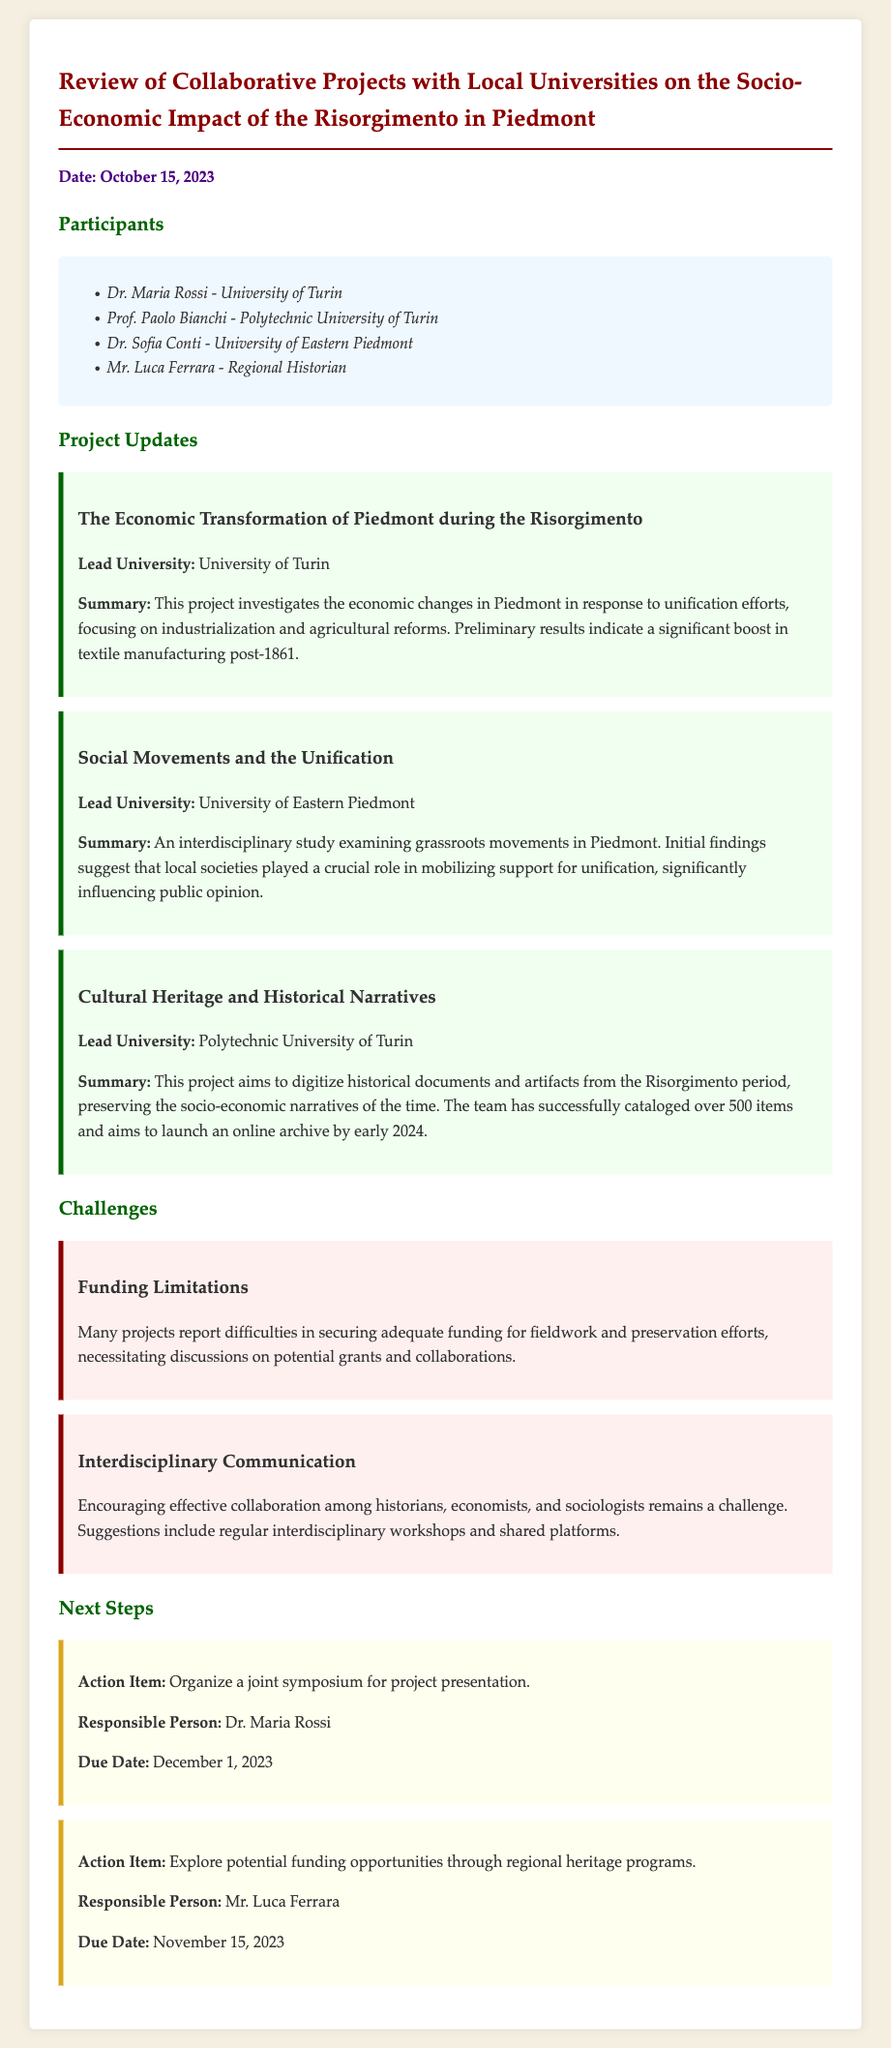What is the date of the meeting? The date of the meeting is stated prominently at the beginning of the document.
Answer: October 15, 2023 Who is the lead university for the project on economic transformation? The lead university for this project is listed under the project updates section.
Answer: University of Turin What is one of the challenges faced by the projects? The challenges are summarized in a section titled "Challenges" where each challenge is detailed.
Answer: Funding Limitations How many items has the Polytechnic University of Turin cataloged so far? This information is provided in the summary of the related project under project updates.
Answer: Over 500 items What is the due date for the action item regarding funding opportunities? The due date for this action item is mentioned within the next steps section.
Answer: November 15, 2023 Which project focuses on social movements? This project is clearly named in the project updates section where its focus is specified.
Answer: Social Movements and the Unification Name one participant in the meeting. The participants' names are listed in the "Participants" section of the document.
Answer: Dr. Maria Rossi What action item is Dr. Maria Rossi responsible for? The next steps section indicates who is responsible for each action item.
Answer: Organize a joint symposium for project presentation 